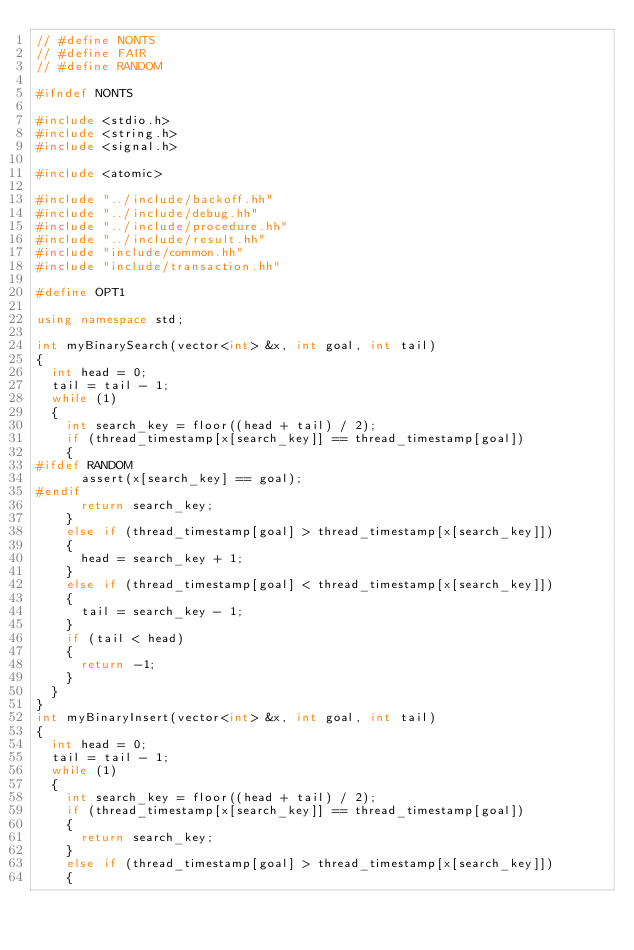<code> <loc_0><loc_0><loc_500><loc_500><_C++_>// #define NONTS
// #define FAIR
// #define RANDOM

#ifndef NONTS

#include <stdio.h>
#include <string.h>
#include <signal.h>

#include <atomic>

#include "../include/backoff.hh"
#include "../include/debug.hh"
#include "../include/procedure.hh"
#include "../include/result.hh"
#include "include/common.hh"
#include "include/transaction.hh"

#define OPT1

using namespace std;

int myBinarySearch(vector<int> &x, int goal, int tail)
{
  int head = 0;
  tail = tail - 1;
  while (1)
  {
    int search_key = floor((head + tail) / 2);
    if (thread_timestamp[x[search_key]] == thread_timestamp[goal])
    {
#ifdef RANDOM
      assert(x[search_key] == goal);
#endif
      return search_key;
    }
    else if (thread_timestamp[goal] > thread_timestamp[x[search_key]])
    {
      head = search_key + 1;
    }
    else if (thread_timestamp[goal] < thread_timestamp[x[search_key]])
    {
      tail = search_key - 1;
    }
    if (tail < head)
    {
      return -1;
    }
  }
}
int myBinaryInsert(vector<int> &x, int goal, int tail)
{
  int head = 0;
  tail = tail - 1;
  while (1)
  {
    int search_key = floor((head + tail) / 2);
    if (thread_timestamp[x[search_key]] == thread_timestamp[goal])
    {
      return search_key;
    }
    else if (thread_timestamp[goal] > thread_timestamp[x[search_key]])
    {</code> 